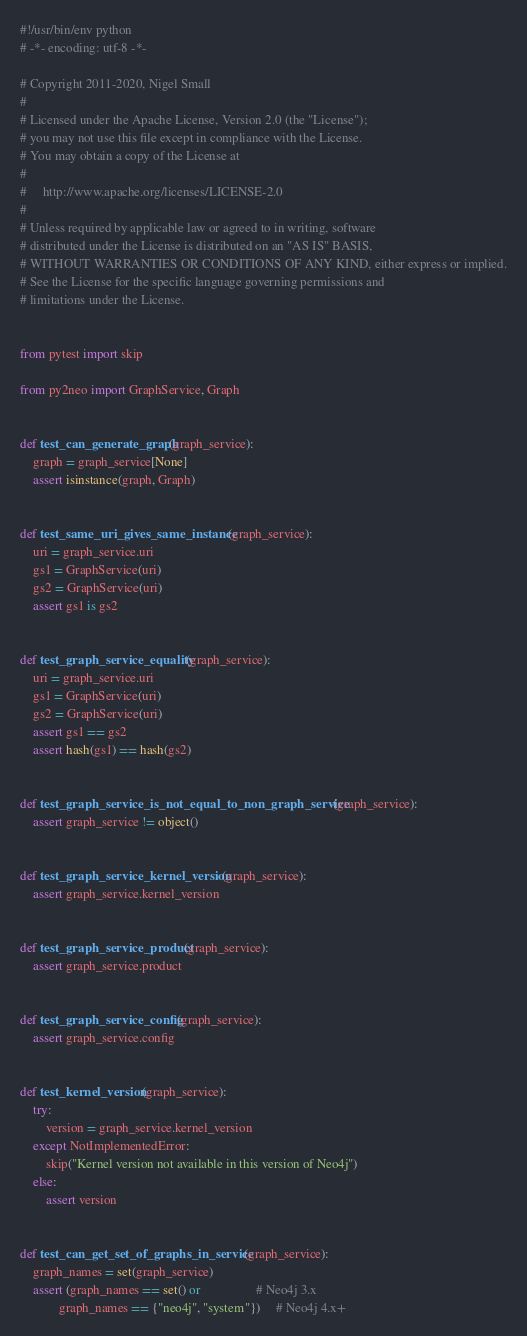<code> <loc_0><loc_0><loc_500><loc_500><_Python_>#!/usr/bin/env python
# -*- encoding: utf-8 -*-

# Copyright 2011-2020, Nigel Small
#
# Licensed under the Apache License, Version 2.0 (the "License");
# you may not use this file except in compliance with the License.
# You may obtain a copy of the License at
#
#     http://www.apache.org/licenses/LICENSE-2.0
#
# Unless required by applicable law or agreed to in writing, software
# distributed under the License is distributed on an "AS IS" BASIS,
# WITHOUT WARRANTIES OR CONDITIONS OF ANY KIND, either express or implied.
# See the License for the specific language governing permissions and
# limitations under the License.


from pytest import skip

from py2neo import GraphService, Graph


def test_can_generate_graph(graph_service):
    graph = graph_service[None]
    assert isinstance(graph, Graph)


def test_same_uri_gives_same_instance(graph_service):
    uri = graph_service.uri
    gs1 = GraphService(uri)
    gs2 = GraphService(uri)
    assert gs1 is gs2


def test_graph_service_equality(graph_service):
    uri = graph_service.uri
    gs1 = GraphService(uri)
    gs2 = GraphService(uri)
    assert gs1 == gs2
    assert hash(gs1) == hash(gs2)


def test_graph_service_is_not_equal_to_non_graph_service(graph_service):
    assert graph_service != object()


def test_graph_service_kernel_version(graph_service):
    assert graph_service.kernel_version


def test_graph_service_product(graph_service):
    assert graph_service.product


def test_graph_service_config(graph_service):
    assert graph_service.config


def test_kernel_version(graph_service):
    try:
        version = graph_service.kernel_version
    except NotImplementedError:
        skip("Kernel version not available in this version of Neo4j")
    else:
        assert version


def test_can_get_set_of_graphs_in_service(graph_service):
    graph_names = set(graph_service)
    assert (graph_names == set() or                 # Neo4j 3.x
            graph_names == {"neo4j", "system"})     # Neo4j 4.x+
</code> 